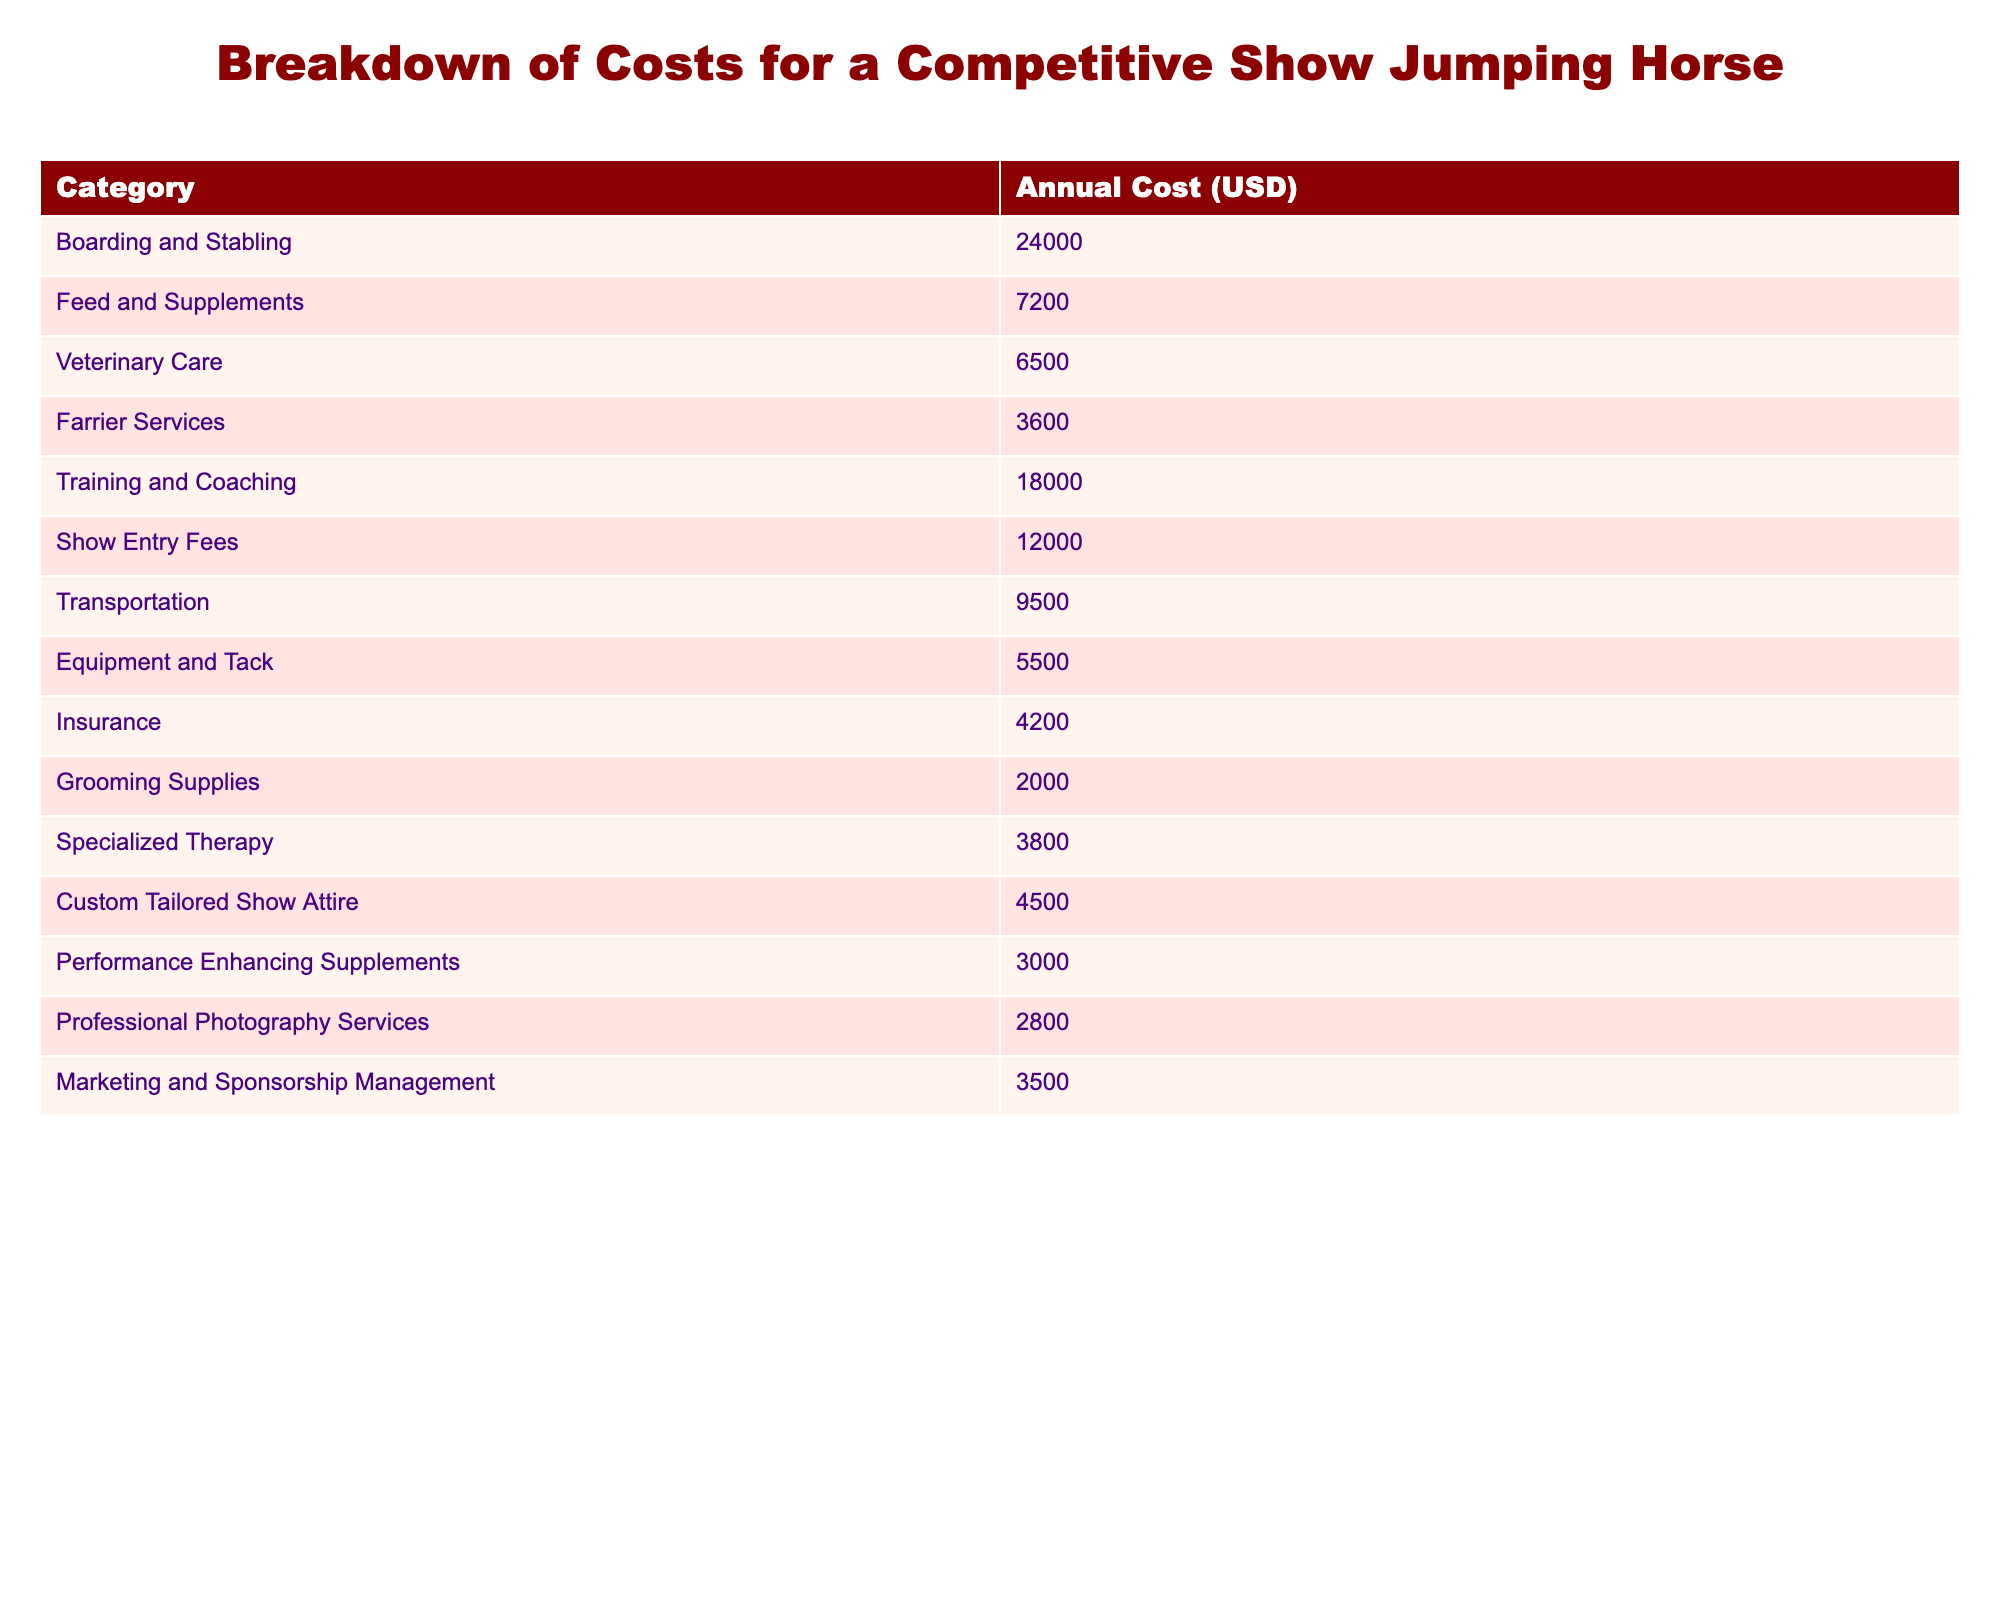What is the total annual cost of veterinary care for a show jumping horse? The table provides a specific value for veterinary care, which is listed as 6,500 USD.
Answer: 6500 What is the highest annual cost category for maintaining a competitive show jumping horse? The table shows that the highest cost category is "Boarding and Stabling," which amounts to 24,000 USD.
Answer: Boarding and Stabling What is the total cost for show entry fees and transportation combined? To find the combined cost, we add show entry fees (12,000 USD) and transportation (9,500 USD): 12,000 + 9,500 = 21,500 USD.
Answer: 21500 How much more is spent on training and coaching compared to grooming supplies? The cost for training and coaching is 18,000 USD and for grooming supplies it is 2,000 USD. The difference is 18,000 - 2,000 = 16,000 USD.
Answer: 16000 Is the cost for feed and supplements greater than the cost for specialized therapy? The cost for feed and supplements is 7,200 USD, while specialized therapy costs 3,800 USD. Since 7,200 is greater than 3,800, the answer is yes.
Answer: Yes What is the average cost of all the categories listed in the table? To find the average, sum all the costs: (24000 + 7200 + 6500 + 3600 + 18000 + 12000 + 9500 + 5500 + 4200 + 2000 + 3800 + 4500 + 3000 + 2800 + 3500 = 51800 USD). There are 15 categories, so the average is 51,800 / 15 = 3,453.33 USD.
Answer: 3453.33 If we exclude insurance, how much would the total annual cost decrease? The insurance cost is 4,200 USD, so we subtract this from the total cost of 51,800 USD: 51,800 - 4,200 = 47,600 USD. The decrease is simply the insurance cost of 4,200 USD.
Answer: 4200 What percentage of the total annual cost is allocated for grooming supplies? First, find the total annual cost (51,800 USD). The grooming supplies cost is 2,000 USD. The percentage is (2,000 / 51,800) * 100 ≈ 3.86%.
Answer: 3.86% What is the combined cost of the least expensive categories? The least expensive categories in the table are grooming supplies (2,000 USD), performance-enhancing supplements (3,000 USD), and professional photography services (2,800 USD). Adding these together, we get 2,000 + 3,000 + 2,800 = 7,800 USD.
Answer: 7800 Do the costs for veterinary care and farrier services together exceed the cost of show entry fees? The cost for veterinary care is 6,500 USD and farrier services are 3,600 USD, which together total 6,500 + 3,600 = 10,100 USD. Since 10,100 is less than the show entry fees (12,000 USD), the answer is no.
Answer: No 